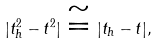Convert formula to latex. <formula><loc_0><loc_0><loc_500><loc_500>| t ^ { 2 } _ { h } - t ^ { 2 } | \cong | t _ { h } - t | ,</formula> 